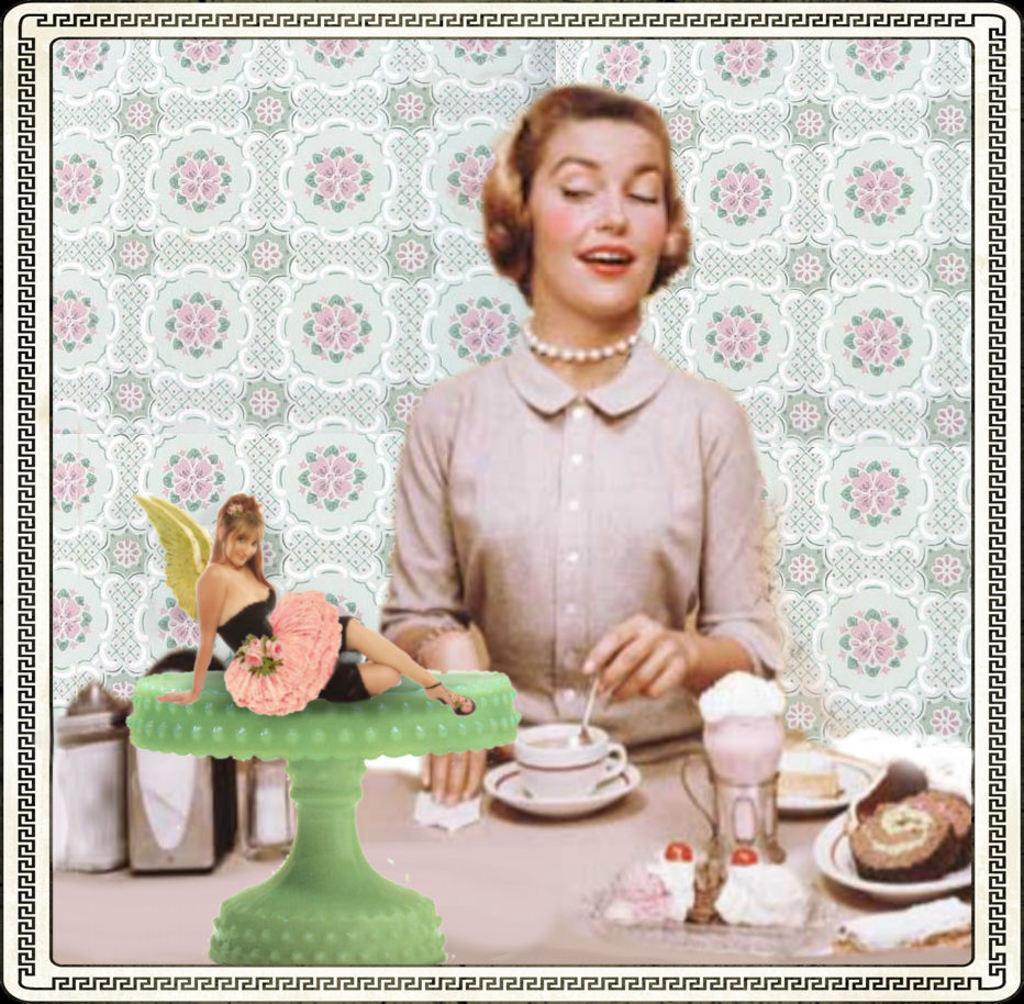In one or two sentences, can you explain what this image depicts? In the picture we can see a photograph of a woman sitting near the table on it we can see a woman mixing a coffee in the cup which is in the saucer and near it we can see cake stand and on it we can see a woman picture sitting with wings and smiling and near to it we can see some tins and some cake slices in the plate and behind her we can see a wall with designs on it. 